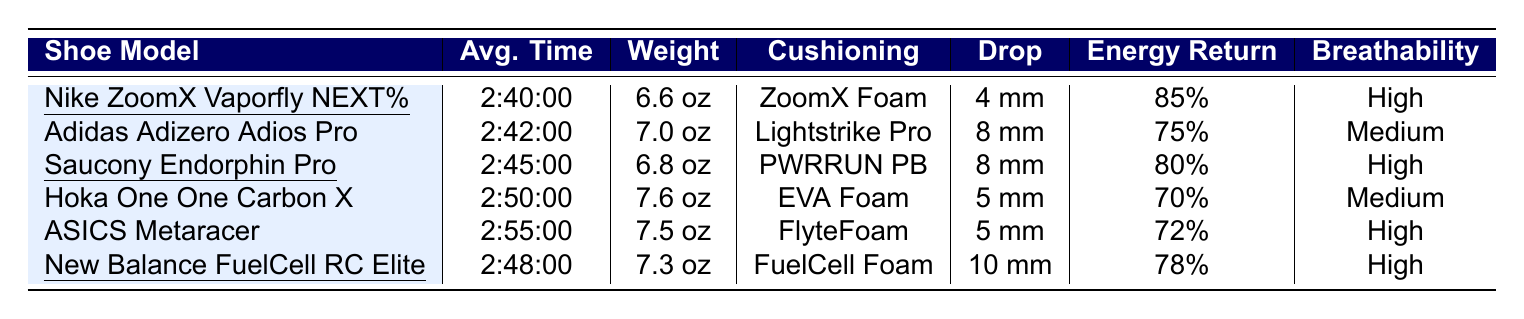What is the average time for the Nike ZoomX Vaporfly NEXT%? The average time for the Nike ZoomX Vaporfly NEXT% can be directly found in the table under the "Avg. Time" column, which shows 2:40:00.
Answer: 2:40:00 Which shoe has the highest energy return? Looking at the "Energy Return" column, the Nike ZoomX Vaporfly NEXT% has the highest percentage at 85%.
Answer: Nike ZoomX Vaporfly NEXT% How much does the Saucony Endorphin Pro weigh? The weight of the Saucony Endorphin Pro is listed directly in the "Weight" column, which shows 6.8 oz.
Answer: 6.8 oz Is the breathability of the ASICS Metaracer high? The breathability for the ASICS Metaracer is listed as "High" in the table, which confirms that it is indeed high.
Answer: Yes What is the difference in average time between the fastest and the slowest shoe? The fastest shoe is the Nike ZoomX Vaporfly NEXT% with an average time of 2:40:00, and the slowest is the ASICS Metaracer with 2:55:00. Calculating the difference: 2:55:00 - 2:40:00 = 15 minutes.
Answer: 15 minutes Which shoes have a cushioning type of “High”? The cushioning types for the shoes are compared; only the Nike ZoomX Vaporfly NEXT% and Saucony Endorphin Pro are listed with "ZoomX Foam" and "PWRRUN PB" respectively, reflecting high cushioning.
Answer: Nike ZoomX Vaporfly NEXT% and Saucony Endorphin Pro What is the average weight of the shoes listed? Adding the weights: (6.6 + 7.0 + 6.8 + 7.6 + 7.5 + 7.3) = 42.8 oz. Dividing by the number of shoes (6) gives an average weight of 42.8/6 = 7.13 oz.
Answer: 7.13 oz Are there any shoes with a drop of 10 mm? The table indicates only one shoe, the New Balance FuelCell RC Elite, having a drop of 10 mm.
Answer: Yes What is the average energy return of shoes with high breathability? The shoes with high breathability are the Nike ZoomX Vaporfly NEXT%, Saucony Endorphin Pro, ASICS Metaracer, and New Balance FuelCell RC Elite. Their energy returns are 85%, 80%, 72%, and 78% respectively. The average is (85 + 80 + 72 + 78) / 4 = 78.75%.
Answer: 78.75% Which shoe weighs the least and what is its weight? The shoe with the least weight is the Nike ZoomX Vaporfly NEXT% at 6.6 oz, as observed in the "Weight" column.
Answer: 6.6 oz 